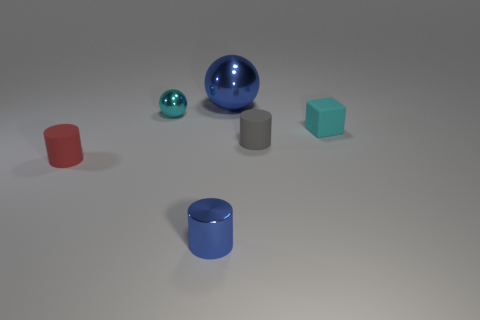Is there any other thing that is the same size as the blue ball?
Offer a very short reply. No. How big is the thing that is right of the small metal cylinder and behind the matte cube?
Provide a short and direct response. Large. What size is the blue thing that is the same material as the blue cylinder?
Offer a terse response. Large. There is a small matte cylinder that is right of the blue metal thing in front of the cyan cube; what is its color?
Your answer should be very brief. Gray. There is a tiny blue object; does it have the same shape as the tiny matte thing that is left of the small gray thing?
Your answer should be compact. Yes. How many other metal cylinders have the same size as the blue cylinder?
Give a very brief answer. 0. What is the material of the gray thing that is the same shape as the tiny red rubber object?
Make the answer very short. Rubber. Do the metal ball in front of the big metal thing and the object that is to the right of the gray matte cylinder have the same color?
Give a very brief answer. Yes. There is a small cyan thing that is right of the tiny metallic cylinder; what is its shape?
Make the answer very short. Cube. The small rubber block is what color?
Your answer should be compact. Cyan. 